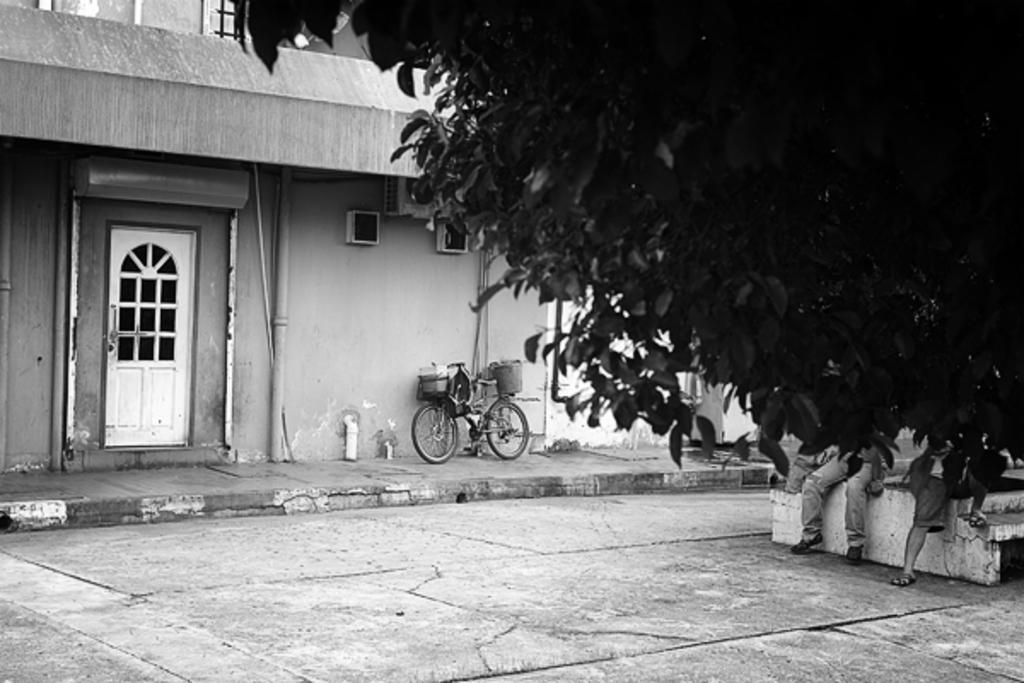Could you give a brief overview of what you see in this image? This is a black and white image, in this image there is a tree beside the tree three men are sitting on a bench, in the background there is a house in the house there is a path on that path there is a bicycle. 